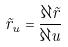<formula> <loc_0><loc_0><loc_500><loc_500>\vec { r } _ { u } = \frac { \partial \vec { r } } { \partial u }</formula> 